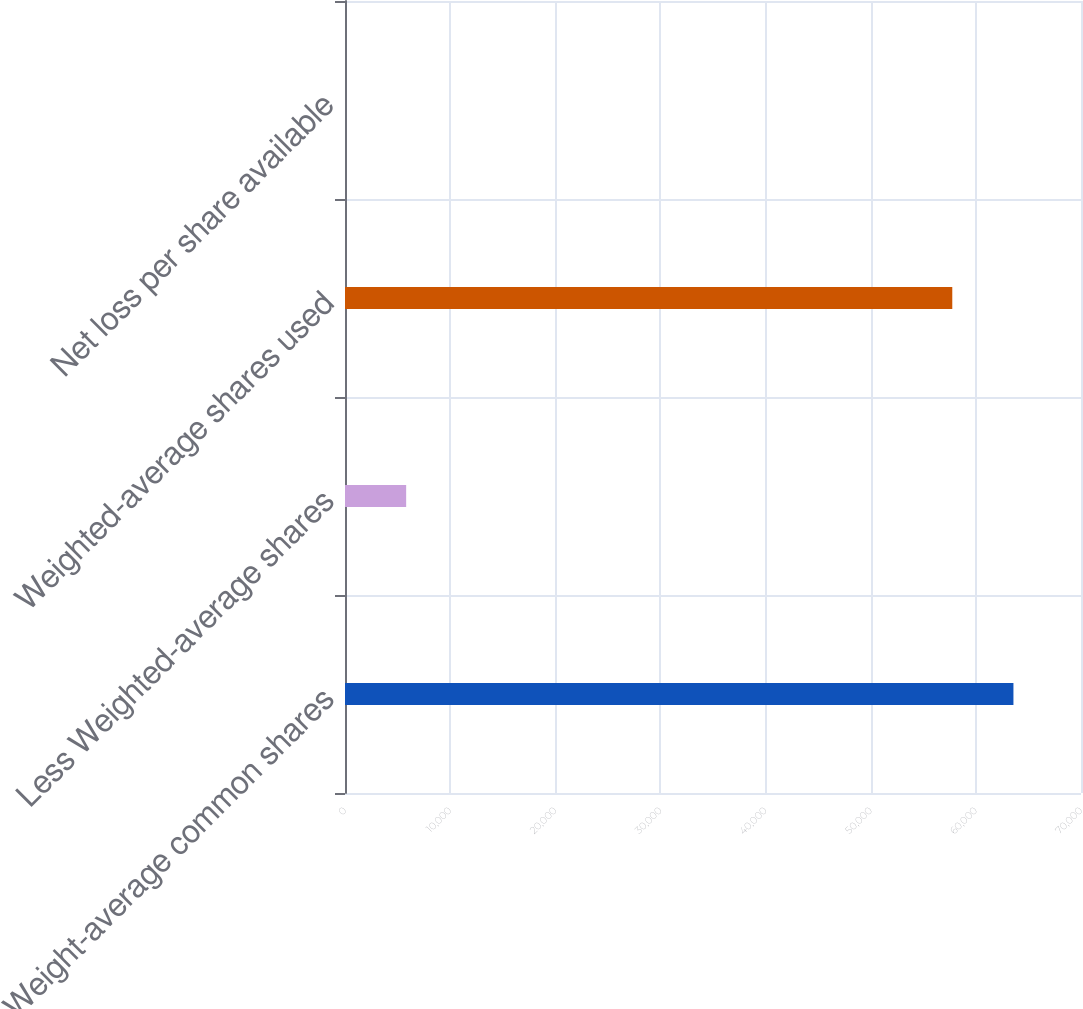Convert chart. <chart><loc_0><loc_0><loc_500><loc_500><bar_chart><fcel>Weight-average common shares<fcel>Less Weighted-average shares<fcel>Weighted-average shares used<fcel>Net loss per share available<nl><fcel>63574.6<fcel>5816.92<fcel>57758<fcel>0.35<nl></chart> 